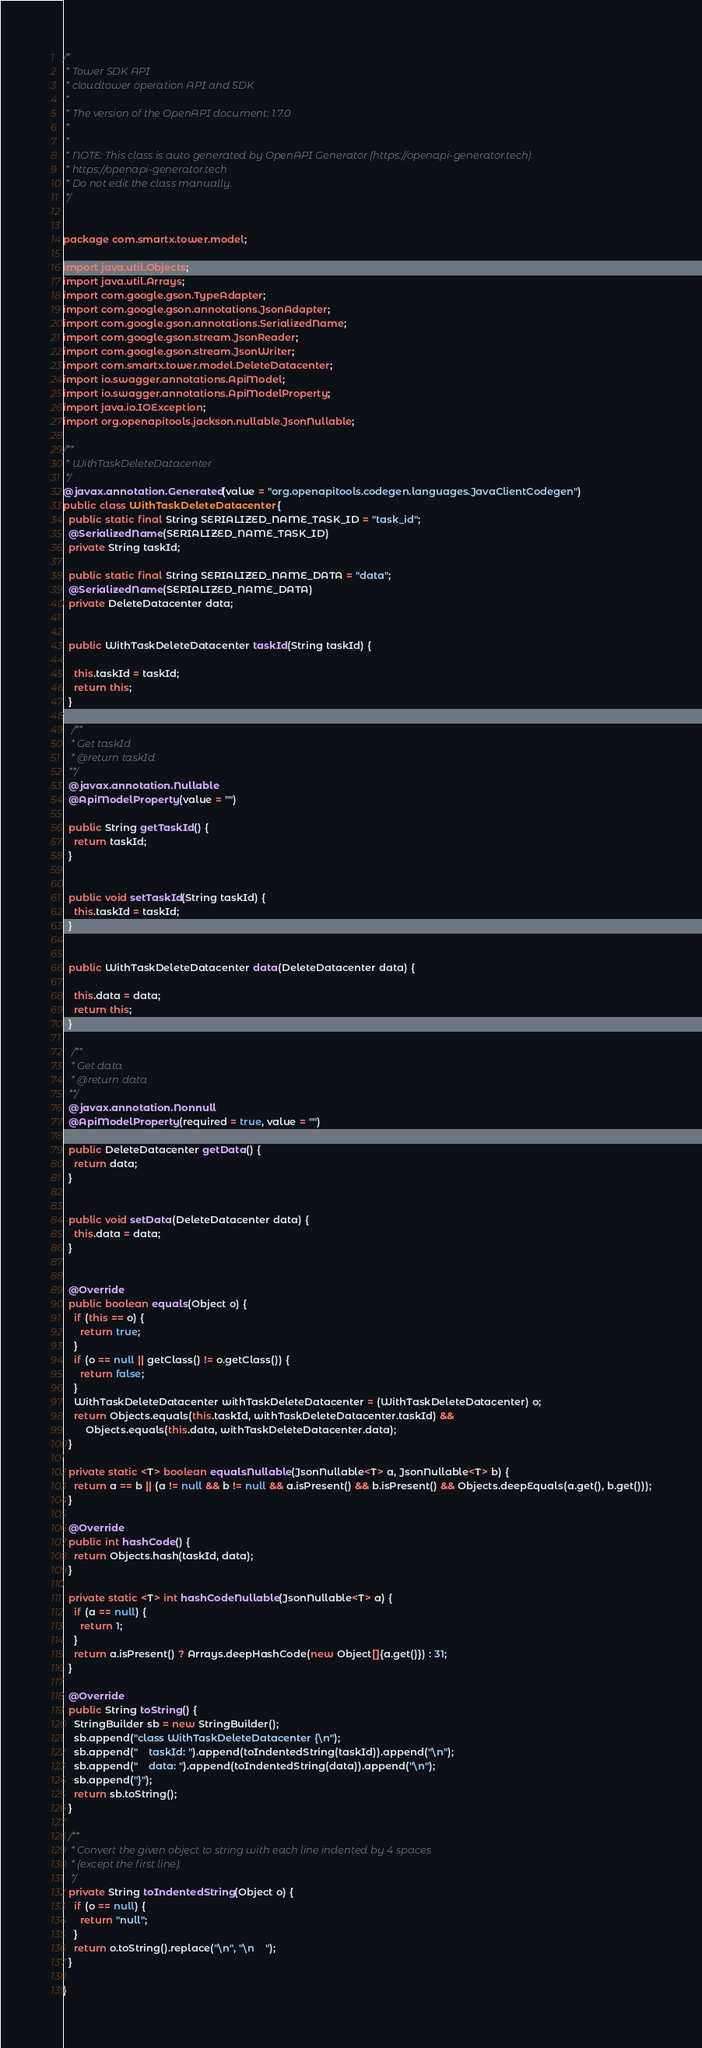<code> <loc_0><loc_0><loc_500><loc_500><_Java_>/*
 * Tower SDK API
 * cloudtower operation API and SDK
 *
 * The version of the OpenAPI document: 1.7.0
 * 
 *
 * NOTE: This class is auto generated by OpenAPI Generator (https://openapi-generator.tech).
 * https://openapi-generator.tech
 * Do not edit the class manually.
 */


package com.smartx.tower.model;

import java.util.Objects;
import java.util.Arrays;
import com.google.gson.TypeAdapter;
import com.google.gson.annotations.JsonAdapter;
import com.google.gson.annotations.SerializedName;
import com.google.gson.stream.JsonReader;
import com.google.gson.stream.JsonWriter;
import com.smartx.tower.model.DeleteDatacenter;
import io.swagger.annotations.ApiModel;
import io.swagger.annotations.ApiModelProperty;
import java.io.IOException;
import org.openapitools.jackson.nullable.JsonNullable;

/**
 * WithTaskDeleteDatacenter
 */
@javax.annotation.Generated(value = "org.openapitools.codegen.languages.JavaClientCodegen")
public class WithTaskDeleteDatacenter {
  public static final String SERIALIZED_NAME_TASK_ID = "task_id";
  @SerializedName(SERIALIZED_NAME_TASK_ID)
  private String taskId;

  public static final String SERIALIZED_NAME_DATA = "data";
  @SerializedName(SERIALIZED_NAME_DATA)
  private DeleteDatacenter data;


  public WithTaskDeleteDatacenter taskId(String taskId) {
    
    this.taskId = taskId;
    return this;
  }

   /**
   * Get taskId
   * @return taskId
  **/
  @javax.annotation.Nullable
  @ApiModelProperty(value = "")

  public String getTaskId() {
    return taskId;
  }


  public void setTaskId(String taskId) {
    this.taskId = taskId;
  }


  public WithTaskDeleteDatacenter data(DeleteDatacenter data) {
    
    this.data = data;
    return this;
  }

   /**
   * Get data
   * @return data
  **/
  @javax.annotation.Nonnull
  @ApiModelProperty(required = true, value = "")

  public DeleteDatacenter getData() {
    return data;
  }


  public void setData(DeleteDatacenter data) {
    this.data = data;
  }


  @Override
  public boolean equals(Object o) {
    if (this == o) {
      return true;
    }
    if (o == null || getClass() != o.getClass()) {
      return false;
    }
    WithTaskDeleteDatacenter withTaskDeleteDatacenter = (WithTaskDeleteDatacenter) o;
    return Objects.equals(this.taskId, withTaskDeleteDatacenter.taskId) &&
        Objects.equals(this.data, withTaskDeleteDatacenter.data);
  }

  private static <T> boolean equalsNullable(JsonNullable<T> a, JsonNullable<T> b) {
    return a == b || (a != null && b != null && a.isPresent() && b.isPresent() && Objects.deepEquals(a.get(), b.get()));
  }

  @Override
  public int hashCode() {
    return Objects.hash(taskId, data);
  }

  private static <T> int hashCodeNullable(JsonNullable<T> a) {
    if (a == null) {
      return 1;
    }
    return a.isPresent() ? Arrays.deepHashCode(new Object[]{a.get()}) : 31;
  }

  @Override
  public String toString() {
    StringBuilder sb = new StringBuilder();
    sb.append("class WithTaskDeleteDatacenter {\n");
    sb.append("    taskId: ").append(toIndentedString(taskId)).append("\n");
    sb.append("    data: ").append(toIndentedString(data)).append("\n");
    sb.append("}");
    return sb.toString();
  }

  /**
   * Convert the given object to string with each line indented by 4 spaces
   * (except the first line).
   */
  private String toIndentedString(Object o) {
    if (o == null) {
      return "null";
    }
    return o.toString().replace("\n", "\n    ");
  }

}

</code> 